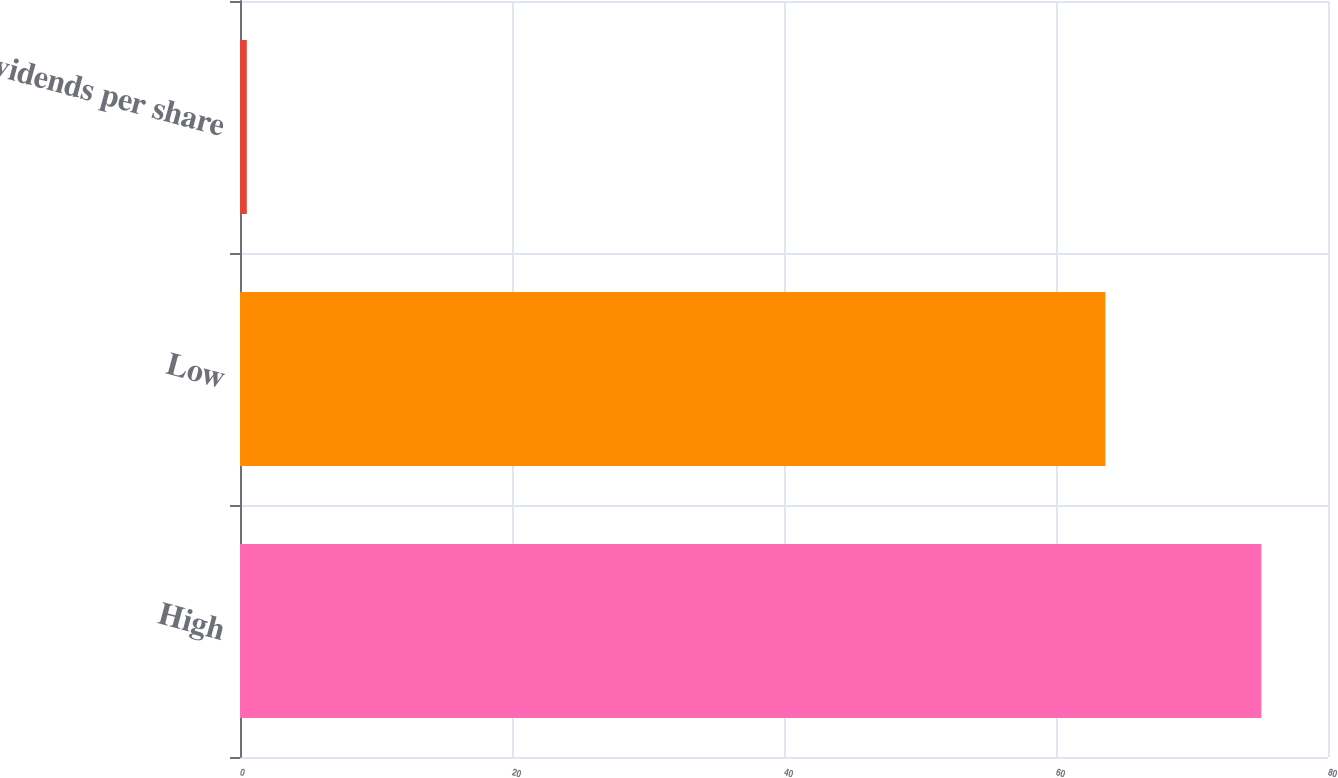Convert chart. <chart><loc_0><loc_0><loc_500><loc_500><bar_chart><fcel>High<fcel>Low<fcel>Dividends per share<nl><fcel>75.1<fcel>63.63<fcel>0.5<nl></chart> 